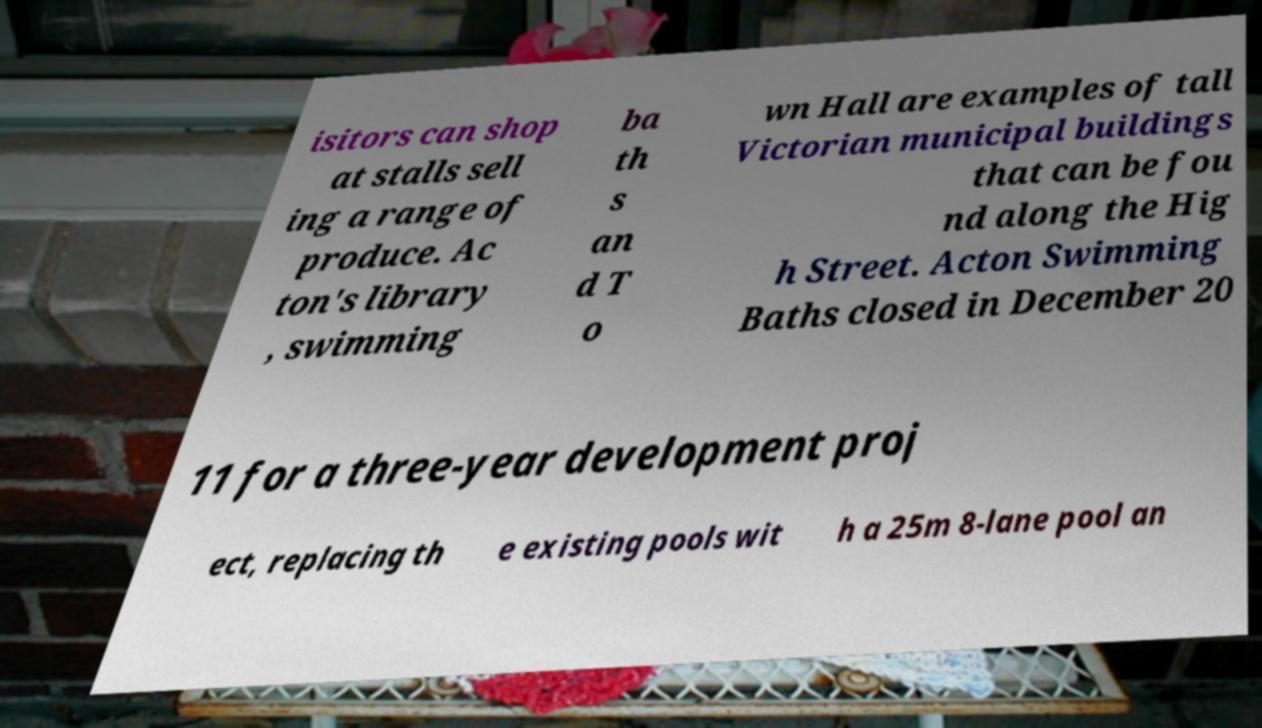Could you extract and type out the text from this image? isitors can shop at stalls sell ing a range of produce. Ac ton's library , swimming ba th s an d T o wn Hall are examples of tall Victorian municipal buildings that can be fou nd along the Hig h Street. Acton Swimming Baths closed in December 20 11 for a three-year development proj ect, replacing th e existing pools wit h a 25m 8-lane pool an 